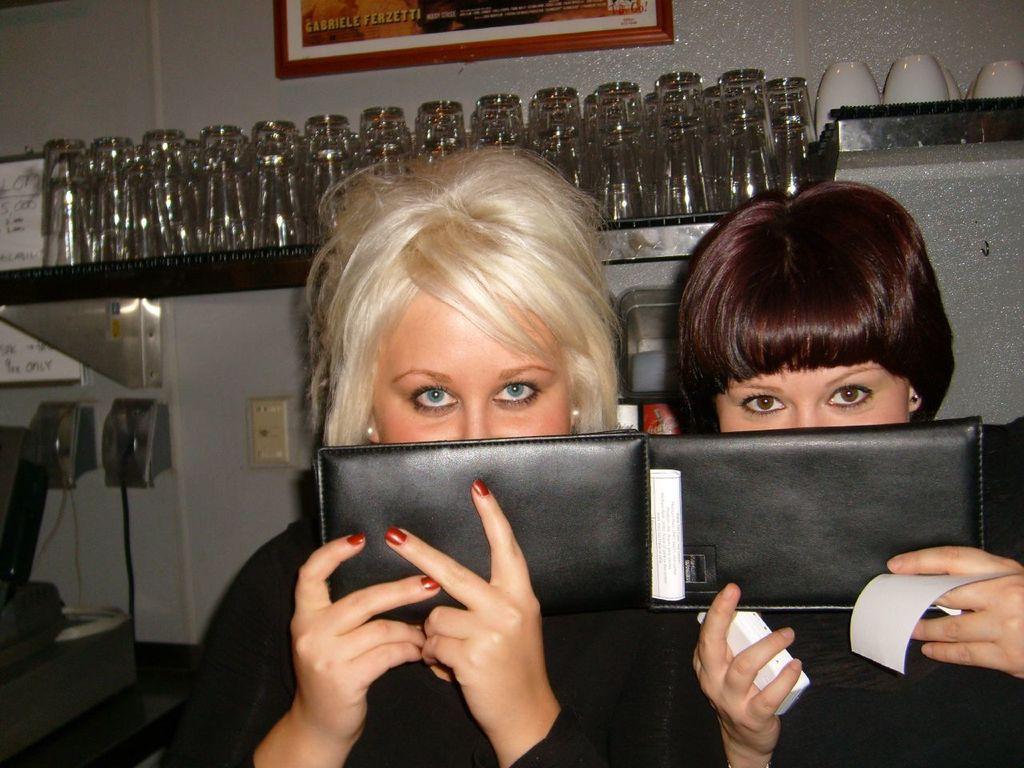Could you give a brief overview of what you see in this image? In this image there are two women holding the pads in their hands, in the background there is a wall, for that wall there are shelves, in that shelves there are glasses and there is a photo frame. 